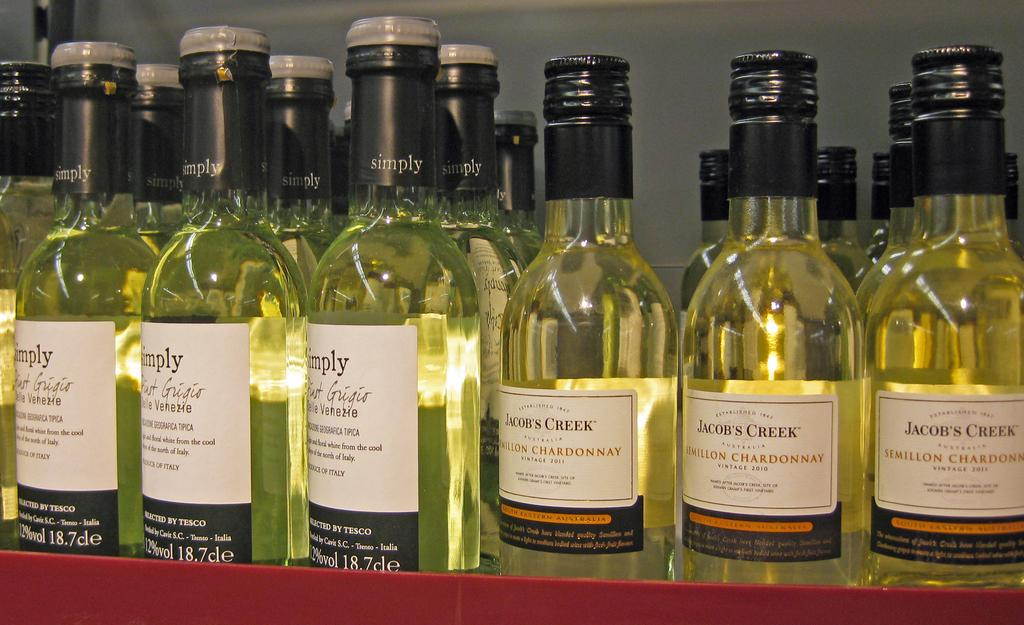<image>
Give a short and clear explanation of the subsequent image. Several alcoholic beverages with the ones on the right being Semillon Chardonnay. 